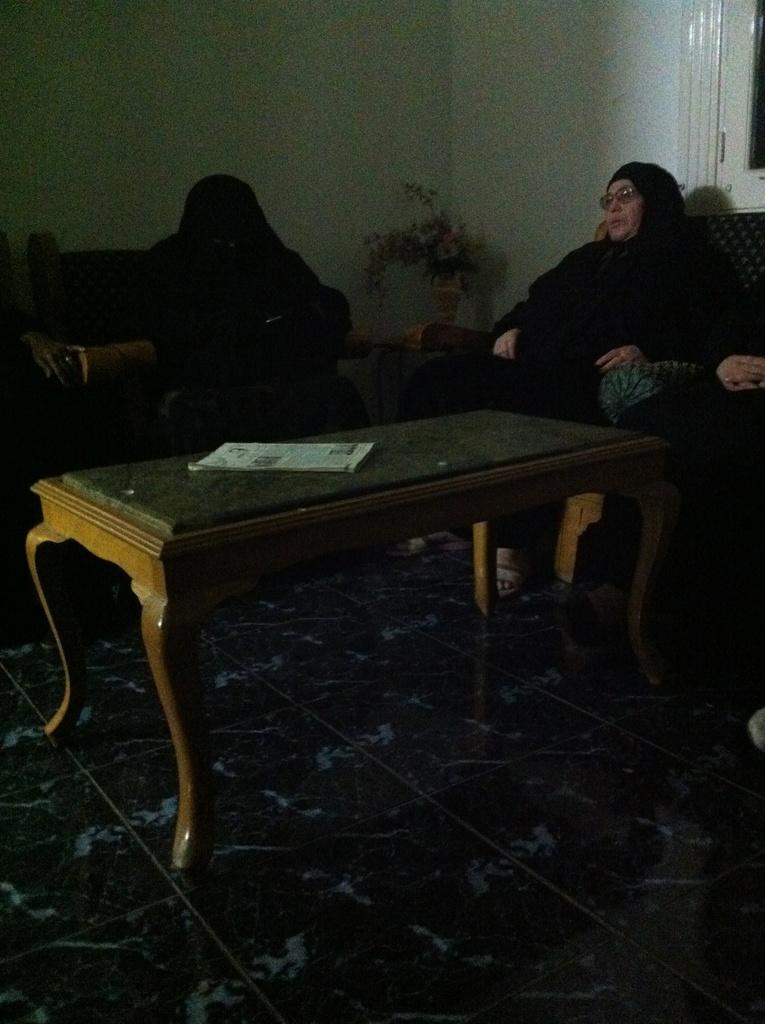Who is present in the image? There is a woman in the image. What is the woman doing in the image? The woman is sitting on a sofa. What object is in front of the woman? There is a table in front of the woman. What is on the table? There is a paper on the table. What type of pen is the zebra holding in the image? There is no zebra or pen present in the image. 